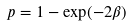Convert formula to latex. <formula><loc_0><loc_0><loc_500><loc_500>p = 1 - \exp ( - 2 \beta )</formula> 